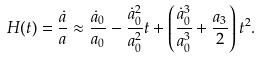Convert formula to latex. <formula><loc_0><loc_0><loc_500><loc_500>H ( t ) = \frac { \dot { a } } { a } \approx \frac { \dot { a } _ { 0 } } { a _ { 0 } } - \frac { \dot { a } _ { 0 } ^ { 2 } } { a _ { 0 } ^ { 2 } } t + \left ( \frac { \dot { a } _ { 0 } ^ { 3 } } { a _ { 0 } ^ { 3 } } + \frac { a _ { 3 } } { 2 } \right ) t ^ { 2 } .</formula> 